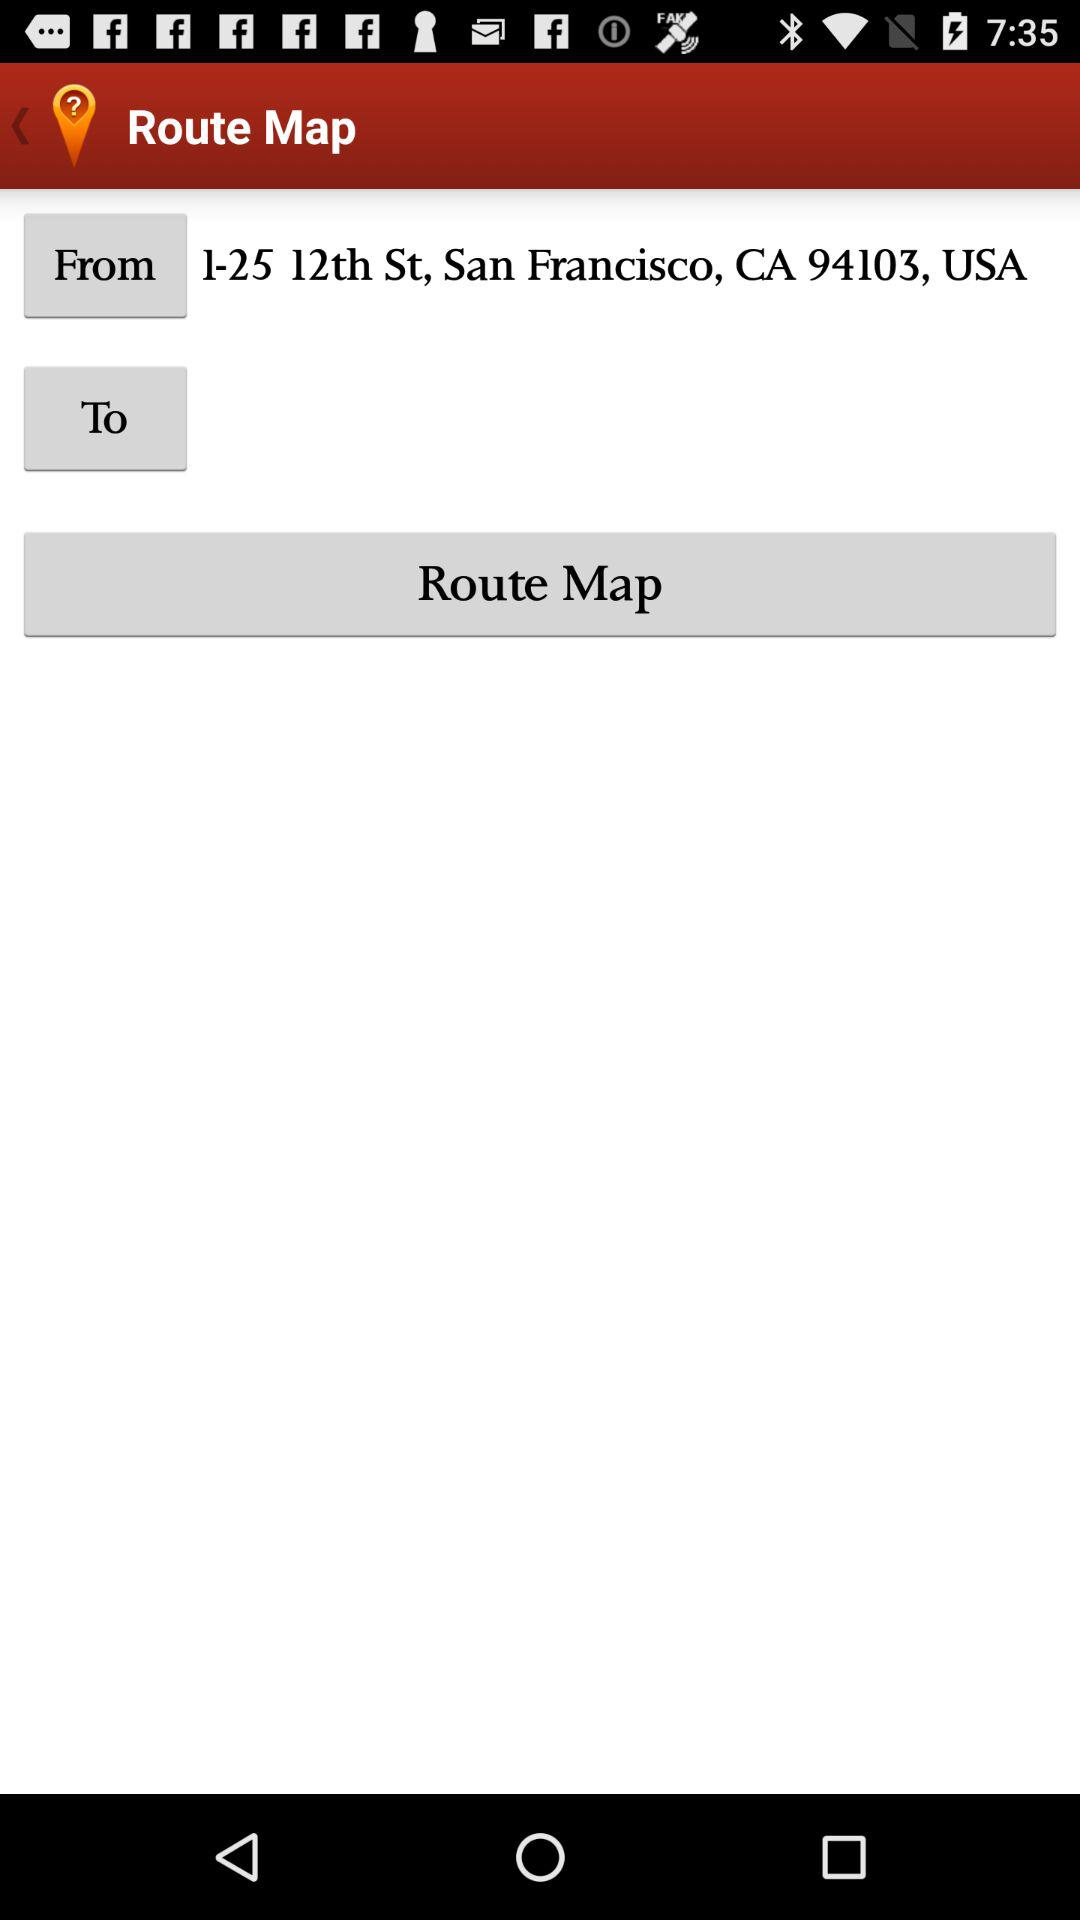What is the address? The address is 1-25 12th St., San Francisco, CA 94103, USA. 